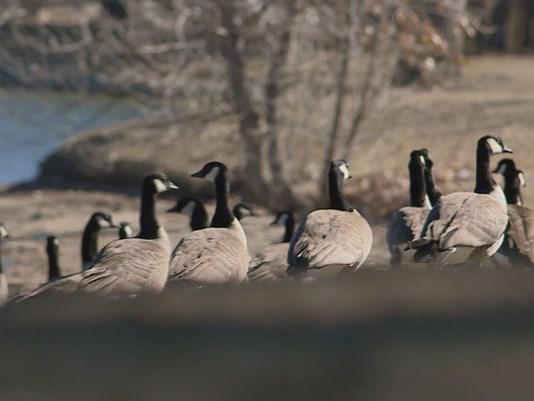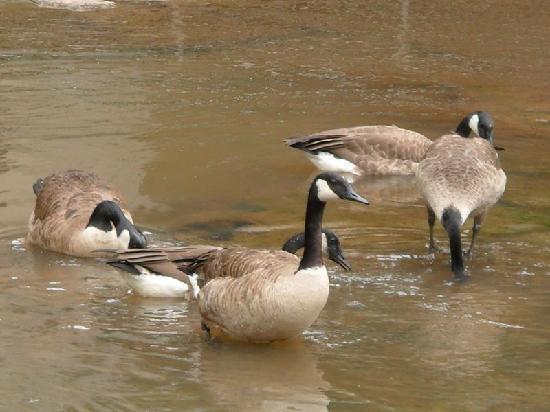The first image is the image on the left, the second image is the image on the right. Analyze the images presented: Is the assertion "There is at least one human pictured with a group of birds." valid? Answer yes or no. No. 